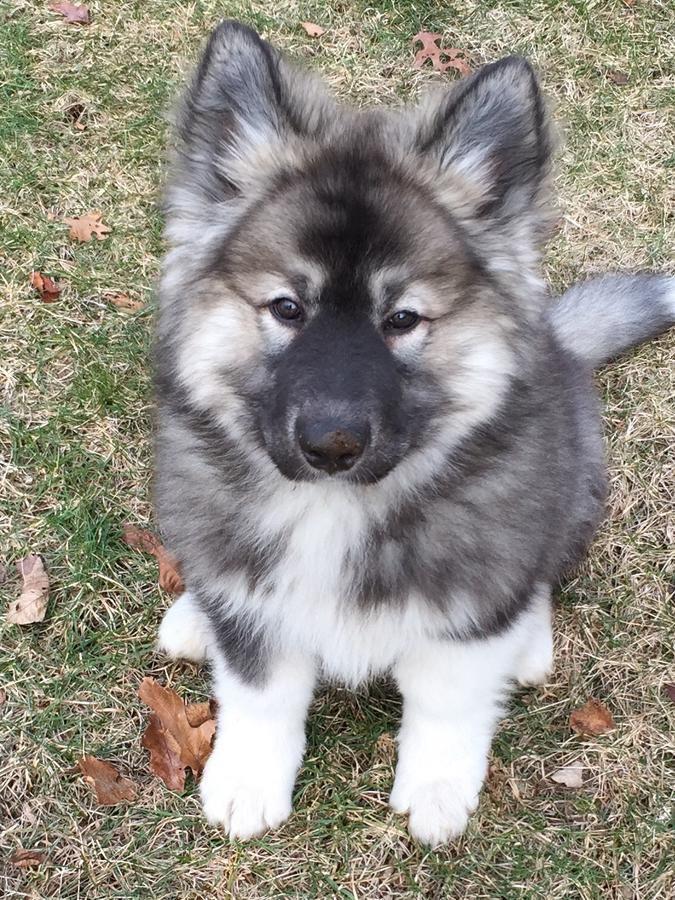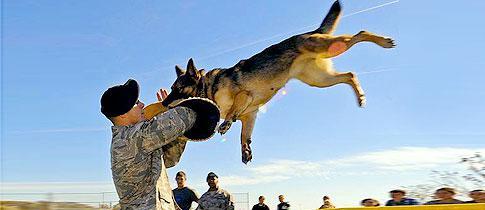The first image is the image on the left, the second image is the image on the right. Evaluate the accuracy of this statement regarding the images: "One of the images shows a dog completely in the air.". Is it true? Answer yes or no. Yes. 